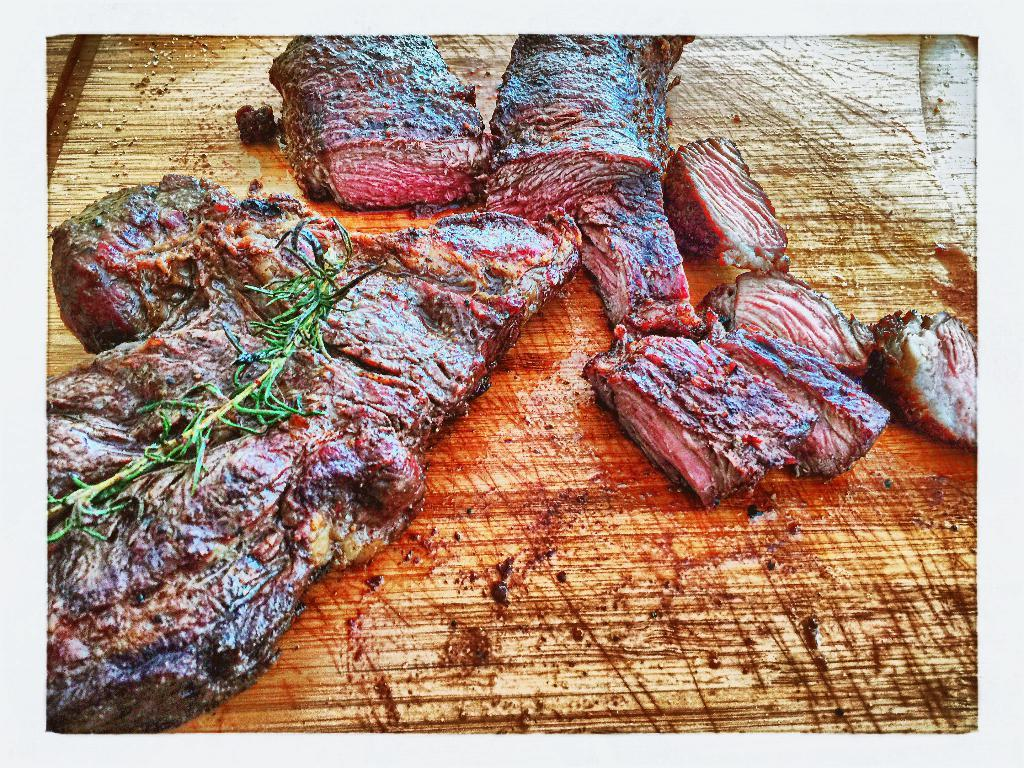What is located at the bottom of the image? There is a board at the bottom of the image. What is on the board? There are meat slices on the board. What type of muscle can be seen flexing on the board in the image? There is no muscle visible in the image; it features a board with meat slices on it. 